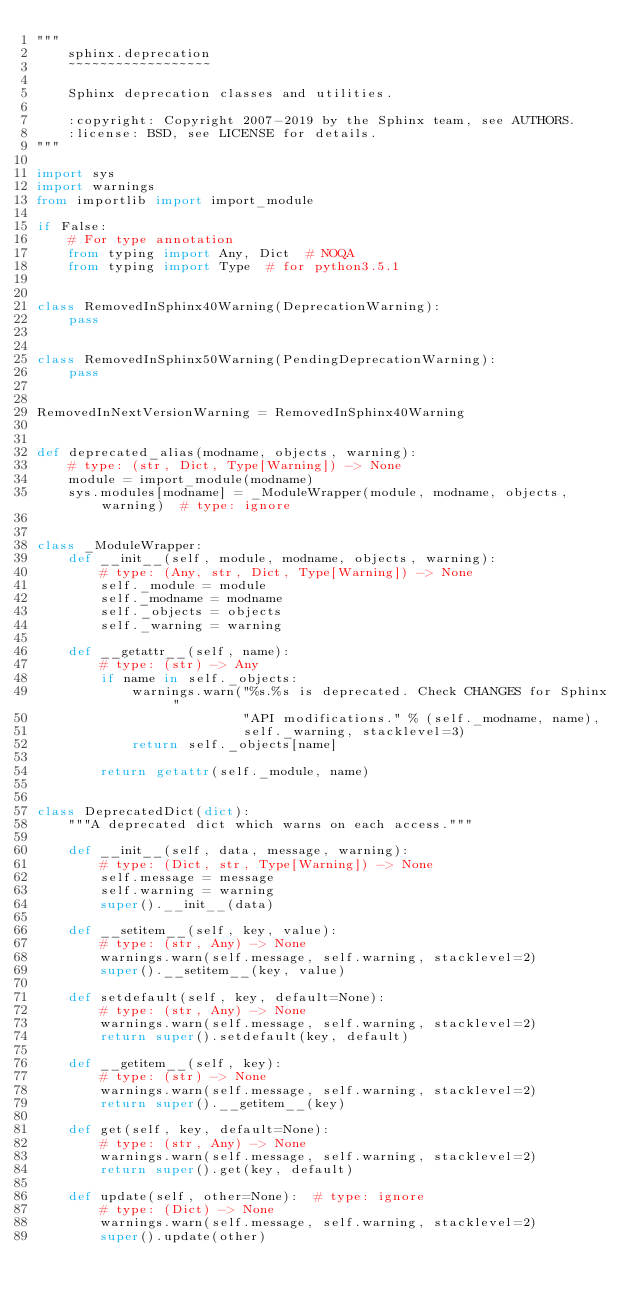Convert code to text. <code><loc_0><loc_0><loc_500><loc_500><_Python_>"""
    sphinx.deprecation
    ~~~~~~~~~~~~~~~~~~

    Sphinx deprecation classes and utilities.

    :copyright: Copyright 2007-2019 by the Sphinx team, see AUTHORS.
    :license: BSD, see LICENSE for details.
"""

import sys
import warnings
from importlib import import_module

if False:
    # For type annotation
    from typing import Any, Dict  # NOQA
    from typing import Type  # for python3.5.1


class RemovedInSphinx40Warning(DeprecationWarning):
    pass


class RemovedInSphinx50Warning(PendingDeprecationWarning):
    pass


RemovedInNextVersionWarning = RemovedInSphinx40Warning


def deprecated_alias(modname, objects, warning):
    # type: (str, Dict, Type[Warning]) -> None
    module = import_module(modname)
    sys.modules[modname] = _ModuleWrapper(module, modname, objects, warning)  # type: ignore


class _ModuleWrapper:
    def __init__(self, module, modname, objects, warning):
        # type: (Any, str, Dict, Type[Warning]) -> None
        self._module = module
        self._modname = modname
        self._objects = objects
        self._warning = warning

    def __getattr__(self, name):
        # type: (str) -> Any
        if name in self._objects:
            warnings.warn("%s.%s is deprecated. Check CHANGES for Sphinx "
                          "API modifications." % (self._modname, name),
                          self._warning, stacklevel=3)
            return self._objects[name]

        return getattr(self._module, name)


class DeprecatedDict(dict):
    """A deprecated dict which warns on each access."""

    def __init__(self, data, message, warning):
        # type: (Dict, str, Type[Warning]) -> None
        self.message = message
        self.warning = warning
        super().__init__(data)

    def __setitem__(self, key, value):
        # type: (str, Any) -> None
        warnings.warn(self.message, self.warning, stacklevel=2)
        super().__setitem__(key, value)

    def setdefault(self, key, default=None):
        # type: (str, Any) -> None
        warnings.warn(self.message, self.warning, stacklevel=2)
        return super().setdefault(key, default)

    def __getitem__(self, key):
        # type: (str) -> None
        warnings.warn(self.message, self.warning, stacklevel=2)
        return super().__getitem__(key)

    def get(self, key, default=None):
        # type: (str, Any) -> None
        warnings.warn(self.message, self.warning, stacklevel=2)
        return super().get(key, default)

    def update(self, other=None):  # type: ignore
        # type: (Dict) -> None
        warnings.warn(self.message, self.warning, stacklevel=2)
        super().update(other)
</code> 